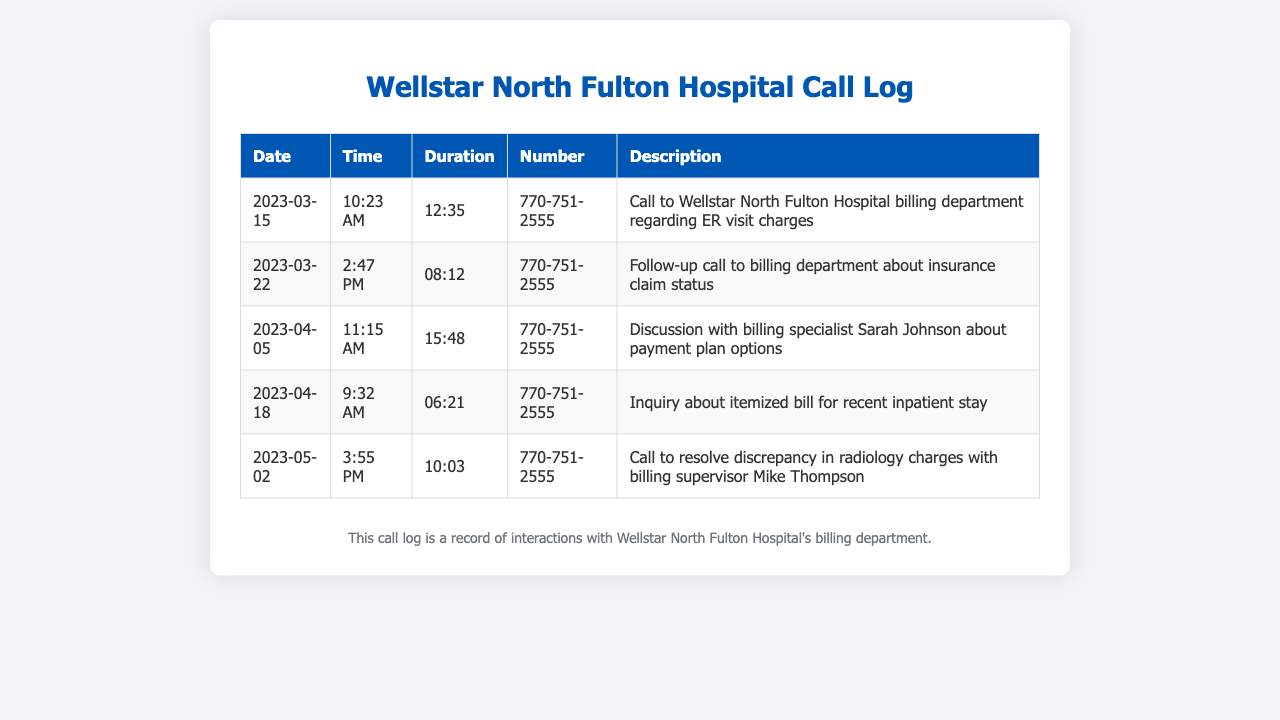What date was the first call made to the billing department? The first call in the log was on 2023-03-15, as indicated in the first row of the call log.
Answer: 2023-03-15 How long was the call on April 5th? The duration of the call on April 5th is stated as 15:48 minutes in the corresponding entry.
Answer: 15:48 Who did you speak with about payment plan options? The document specifies that the caller discussed payment plan options with Sarah Johnson during the call on April 5th.
Answer: Sarah Johnson What was the purpose of the call on May 2nd? The call on May 2nd was to resolve a discrepancy in radiology charges, as noted in its description.
Answer: Resolve discrepancy in radiology charges Which call involved an inquiry about an itemized bill? The call on April 18th is specifically about inquiring about an itemized bill for a recent inpatient stay.
Answer: April 18th How many calls are listed in the document? The call log contains a total of five entries, each representing a different call.
Answer: Five What time was the follow-up call made? The follow-up call to the billing department took place at 2:47 PM on March 22nd, as seen in the log.
Answer: 2:47 PM What is the billing department's contact number? The number used for all calls to the billing department is recorded as 770-751-2555 throughout the log.
Answer: 770-751-2555 Who is the billing supervisor mentioned in the document? Mike Thompson is identified as the billing supervisor in the call made to resolve discrepancies on May 2nd.
Answer: Mike Thompson 